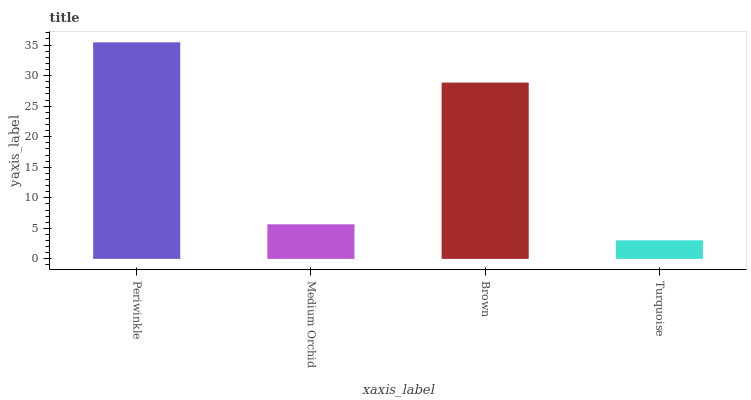Is Turquoise the minimum?
Answer yes or no. Yes. Is Periwinkle the maximum?
Answer yes or no. Yes. Is Medium Orchid the minimum?
Answer yes or no. No. Is Medium Orchid the maximum?
Answer yes or no. No. Is Periwinkle greater than Medium Orchid?
Answer yes or no. Yes. Is Medium Orchid less than Periwinkle?
Answer yes or no. Yes. Is Medium Orchid greater than Periwinkle?
Answer yes or no. No. Is Periwinkle less than Medium Orchid?
Answer yes or no. No. Is Brown the high median?
Answer yes or no. Yes. Is Medium Orchid the low median?
Answer yes or no. Yes. Is Medium Orchid the high median?
Answer yes or no. No. Is Brown the low median?
Answer yes or no. No. 